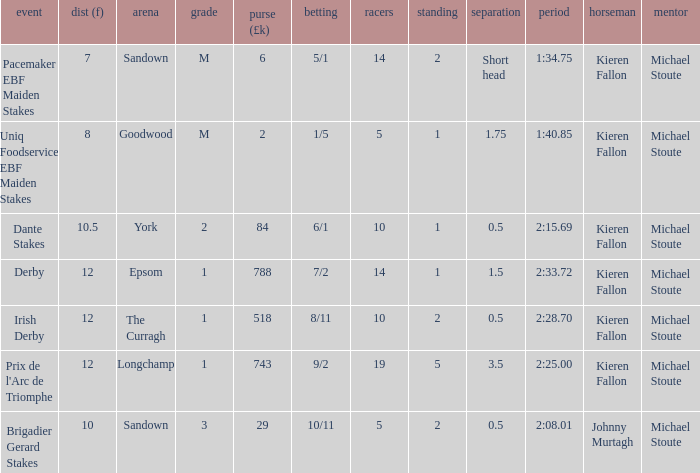Name the runners for longchamp 19.0. 